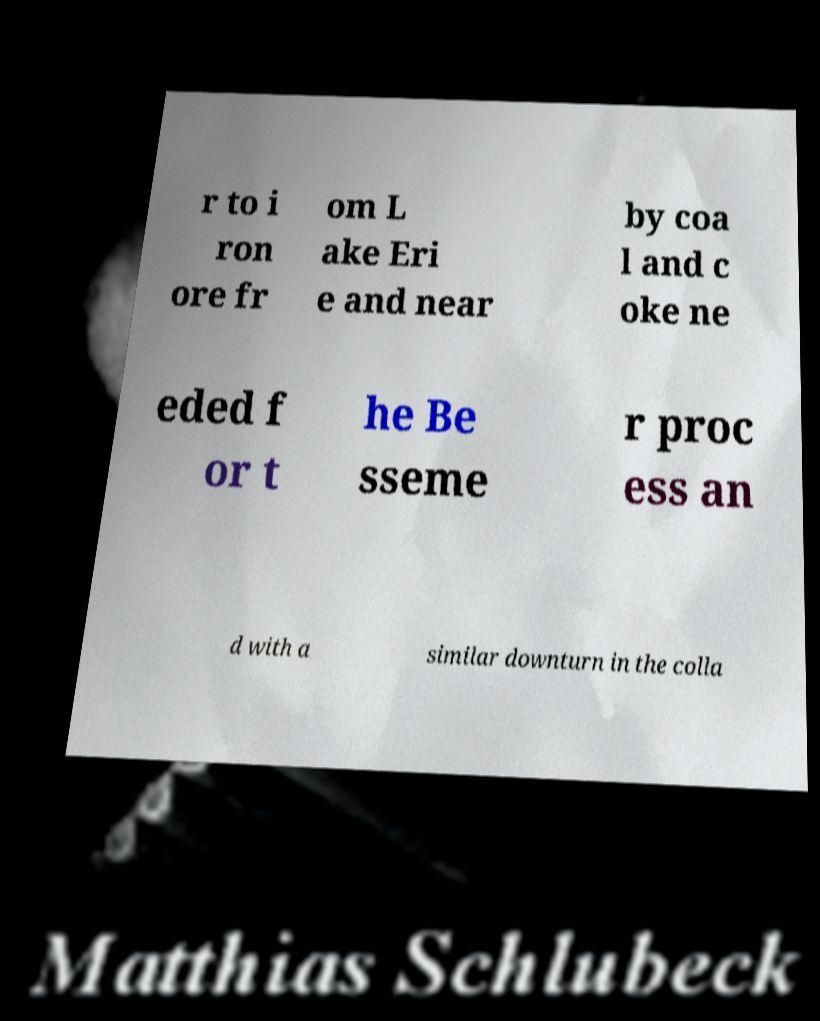What messages or text are displayed in this image? I need them in a readable, typed format. r to i ron ore fr om L ake Eri e and near by coa l and c oke ne eded f or t he Be sseme r proc ess an d with a similar downturn in the colla 